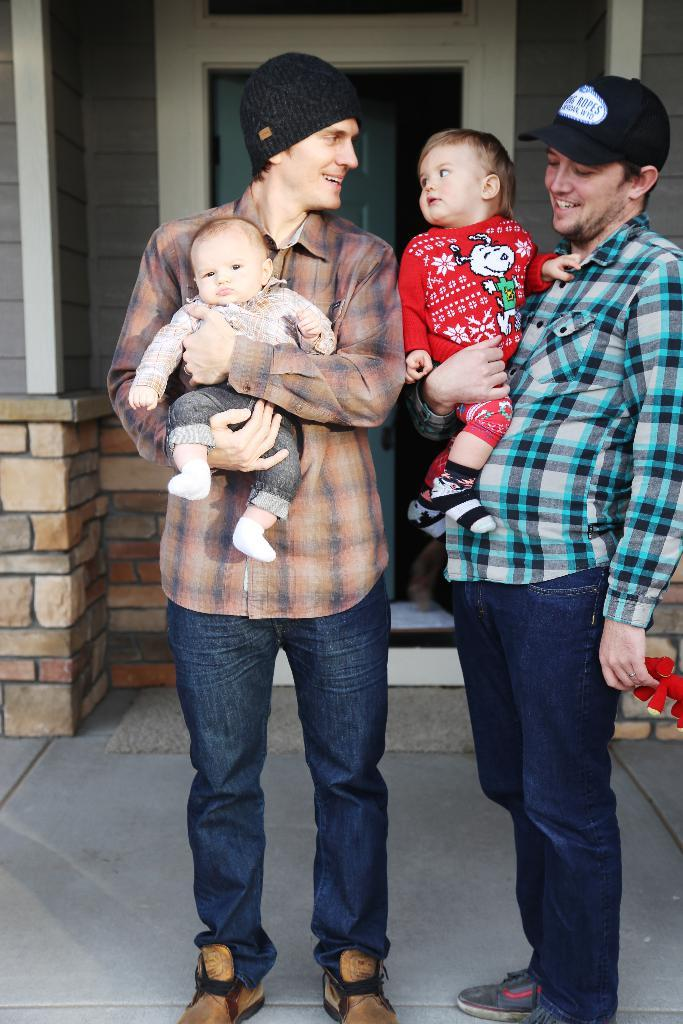What is the main subject of the image? The main subject of the image is a group of people. Can you describe the attire of the people in the image? The people in the image are wearing different color dresses. Are there any accessories visible on the people in the image? Yes, two people are wearing caps. What can be seen in the background of the image? There is a house in the background of the image. What type of jam is being harvested in the plantation behind the people in the image? There is no plantation or jam present in the image; it features a group of people and a house in the background. 